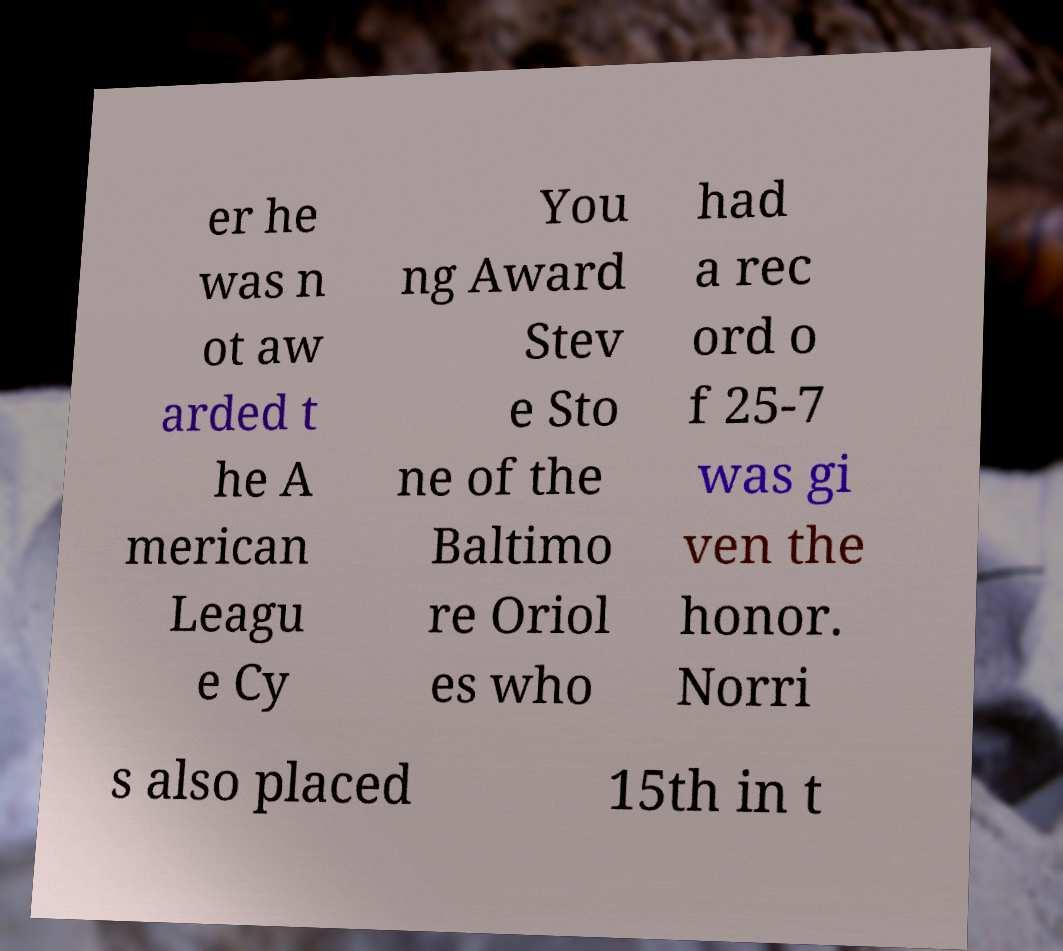Can you read and provide the text displayed in the image?This photo seems to have some interesting text. Can you extract and type it out for me? er he was n ot aw arded t he A merican Leagu e Cy You ng Award Stev e Sto ne of the Baltimo re Oriol es who had a rec ord o f 25-7 was gi ven the honor. Norri s also placed 15th in t 